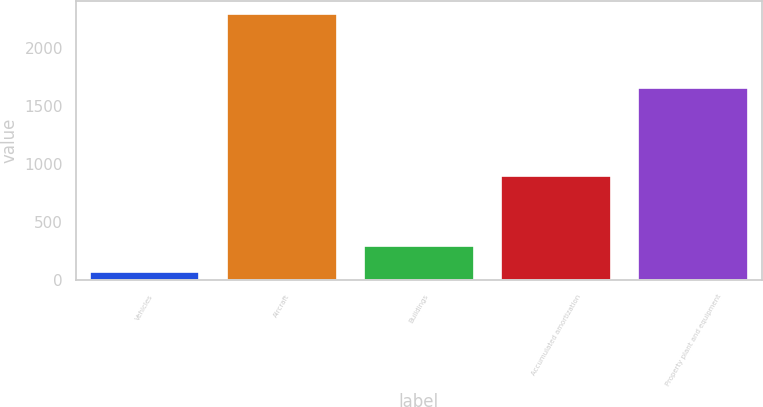<chart> <loc_0><loc_0><loc_500><loc_500><bar_chart><fcel>Vehicles<fcel>Aircraft<fcel>Buildings<fcel>Accumulated amortization<fcel>Property plant and equipment<nl><fcel>68<fcel>2291<fcel>290.3<fcel>896<fcel>1653<nl></chart> 